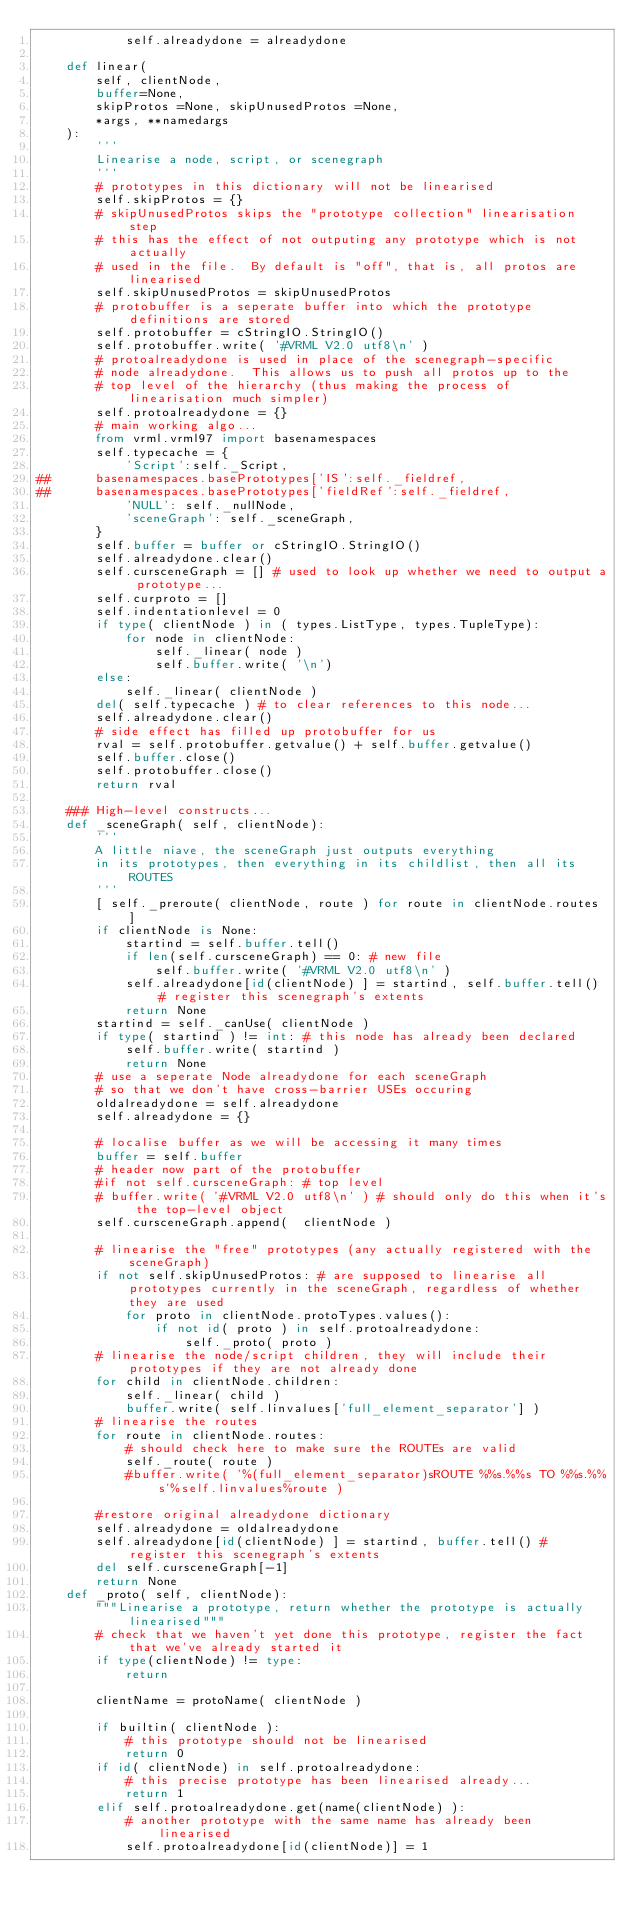<code> <loc_0><loc_0><loc_500><loc_500><_Python_>            self.alreadydone = alreadydone
        
    def linear(
        self, clientNode,
        buffer=None,
        skipProtos =None, skipUnusedProtos =None,
        *args, **namedargs
    ):
        '''
        Linearise a node, script, or scenegraph
        '''
        # prototypes in this dictionary will not be linearised
        self.skipProtos = {}
        # skipUnusedProtos skips the "prototype collection" linearisation step
        # this has the effect of not outputing any prototype which is not actually
        # used in the file.  By default is "off", that is, all protos are linearised
        self.skipUnusedProtos = skipUnusedProtos
        # protobuffer is a seperate buffer into which the prototype definitions are stored
        self.protobuffer = cStringIO.StringIO()
        self.protobuffer.write( '#VRML V2.0 utf8\n' )
        # protoalreadydone is used in place of the scenegraph-specific
        # node alreadydone.  This allows us to push all protos up to the
        # top level of the hierarchy (thus making the process of linearisation much simpler)
        self.protoalreadydone = {}
        # main working algo...
        from vrml.vrml97 import basenamespaces
        self.typecache = {
            'Script':self._Script,
##			basenamespaces.basePrototypes['IS':self._fieldref,
##			basenamespaces.basePrototypes['fieldRef':self._fieldref,
            'NULL': self._nullNode,
            'sceneGraph': self._sceneGraph,
        }
        self.buffer = buffer or cStringIO.StringIO()
        self.alreadydone.clear()
        self.cursceneGraph = [] # used to look up whether we need to output a prototype...
        self.curproto = []
        self.indentationlevel = 0
        if type( clientNode ) in ( types.ListType, types.TupleType):
            for node in clientNode:
                self._linear( node )
                self.buffer.write( '\n')
        else:
            self._linear( clientNode )
        del( self.typecache ) # to clear references to this node...
        self.alreadydone.clear()
        # side effect has filled up protobuffer for us
        rval = self.protobuffer.getvalue() + self.buffer.getvalue()
        self.buffer.close()
        self.protobuffer.close()
        return rval

    ### High-level constructs...
    def _sceneGraph( self, clientNode):
        '''
        A little niave, the sceneGraph just outputs everything
        in its prototypes, then everything in its childlist, then all its ROUTES
        '''
        [ self._preroute( clientNode, route ) for route in clientNode.routes ]
        if clientNode is None:
            startind = self.buffer.tell()
            if len(self.cursceneGraph) == 0: # new file
                self.buffer.write( '#VRML V2.0 utf8\n' )
            self.alreadydone[id(clientNode) ] = startind, self.buffer.tell() # register this scenegraph's extents
            return None
        startind = self._canUse( clientNode )
        if type( startind ) != int: # this node has already been declared
            self.buffer.write( startind )
            return None
        # use a seperate Node alreadydone for each sceneGraph
        # so that we don't have cross-barrier USEs occuring
        oldalreadydone = self.alreadydone
        self.alreadydone = {}
        
        # localise buffer as we will be accessing it many times
        buffer = self.buffer
        # header now part of the protobuffer
        #if not self.cursceneGraph: # top level
        #	buffer.write( '#VRML V2.0 utf8\n' ) # should only do this when it's the top-level object
        self.cursceneGraph.append(  clientNode )

        # linearise the "free" prototypes (any actually registered with the sceneGraph)
        if not self.skipUnusedProtos: # are supposed to linearise all prototypes currently in the sceneGraph, regardless of whether they are used
            for proto in clientNode.protoTypes.values():
                if not id( proto ) in self.protoalreadydone:
                    self._proto( proto )
        # linearise the node/script children, they will include their prototypes if they are not already done
        for child in clientNode.children:
            self._linear( child )
            buffer.write( self.linvalues['full_element_separator'] )
        # linearise the routes
        for route in clientNode.routes:
            # should check here to make sure the ROUTEs are valid
            self._route( route )
            #buffer.write( '%(full_element_separator)sROUTE %%s.%%s TO %%s.%%s'%self.linvalues%route )
        
        #restore original alreadydone dictionary
        self.alreadydone = oldalreadydone
        self.alreadydone[id(clientNode) ] = startind, buffer.tell() # register this scenegraph's extents
        del self.cursceneGraph[-1]
        return None
    def _proto( self, clientNode):
        """Linearise a prototype, return whether the prototype is actually linearised"""
        # check that we haven't yet done this prototype, register the fact that we've already started it
        if type(clientNode) != type:
            return

        clientName = protoName( clientNode )
        
        if builtin( clientNode ):
            # this prototype should not be linearised
            return 0
        if id( clientNode) in self.protoalreadydone:
            # this precise prototype has been linearised already...
            return 1
        elif self.protoalreadydone.get(name(clientNode) ):
            # another prototype with the same name has already been linearised
            self.protoalreadydone[id(clientNode)] = 1</code> 